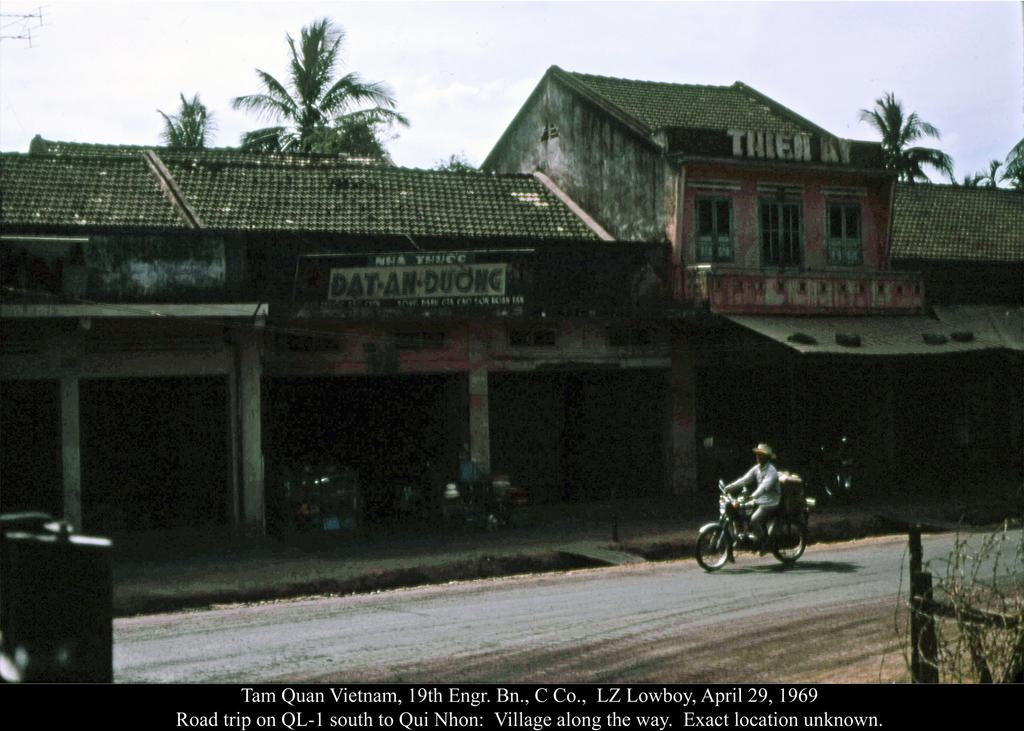What type of structure is present in the image? There is a building in the image. What feature can be seen on the building? The building has windows. What other objects are visible in the image? There are trees and a board attached to the wall of the building. What is the person in the image doing? A person is riding a vehicle in the image. What is the color of the sky in the image? The sky is blue and white in color. How many cakes are being divided among the people in the image? There are no cakes present in the image. What type of cannon is being fired in the image? There is no cannon present in the image. 